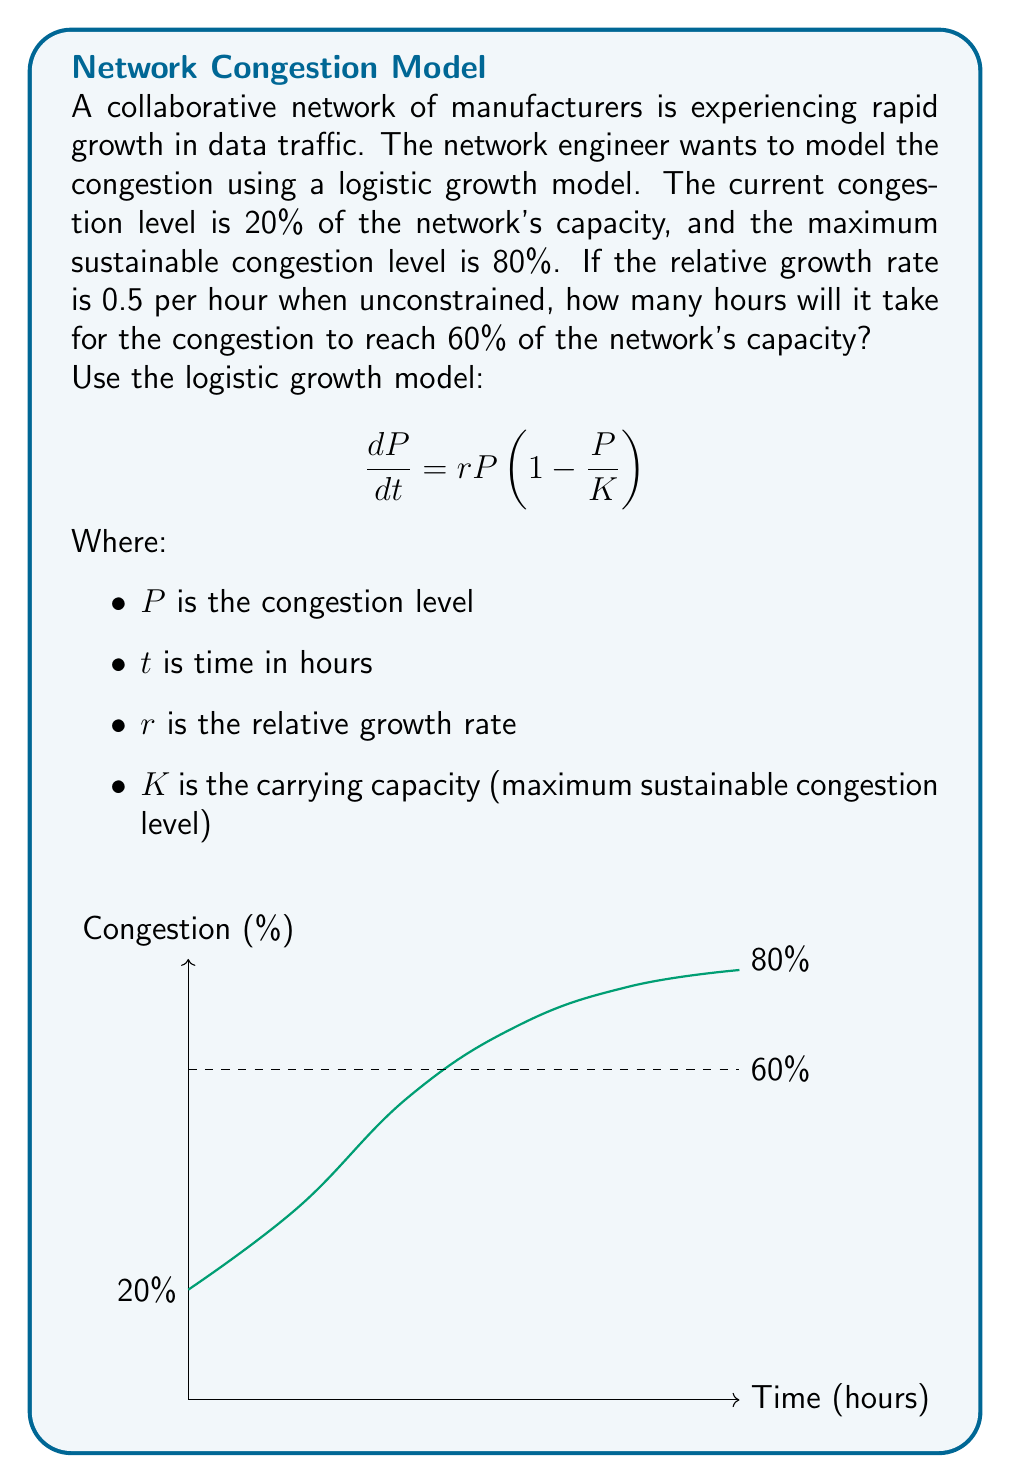Solve this math problem. Let's solve this step-by-step:

1) First, we need to set up our logistic growth equation:

   $$\frac{dP}{dt} = 0.5P(1-\frac{P}{80})$$

2) The solution to this differential equation is:

   $$P(t) = \frac{80}{1 + Ce^{-0.5t}}$$

   Where $C$ is a constant we need to determine.

3) We know that at $t=0$, $P(0) = 20$. Let's use this to find $C$:

   $$20 = \frac{80}{1 + C}$$
   $$1 + C = 4$$
   $$C = 3$$

4) So our specific solution is:

   $$P(t) = \frac{80}{1 + 3e^{-0.5t}}$$

5) Now, we want to find $t$ when $P(t) = 60$. Let's substitute this:

   $$60 = \frac{80}{1 + 3e^{-0.5t}}$$

6) Solving for $t$:

   $$1 + 3e^{-0.5t} = \frac{80}{60} = \frac{4}{3}$$
   $$3e^{-0.5t} = \frac{1}{3}$$
   $$e^{-0.5t} = \frac{1}{9}$$
   $$-0.5t = \ln(\frac{1}{9}) = -\ln(9)$$
   $$t = 2\ln(9) \approx 4.39$$

Therefore, it will take approximately 4.39 hours for the congestion to reach 60% of the network's capacity.
Answer: 4.39 hours 